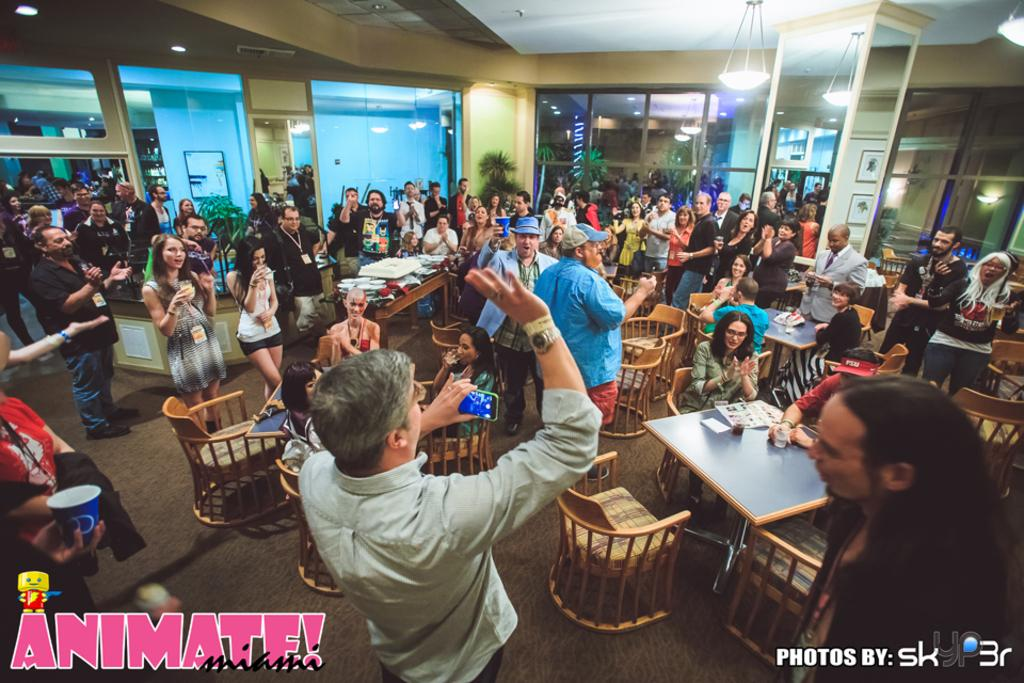What is the man in the image holding? The man is holding a mobile phone. What is the man wearing in the image? The man is wearing a shirt. How many people are in the image? There are other people in the image, in addition to the man. What are some of the people in the image doing? Some people are sitting on chairs, and some people are standing. Where is the light located in the image? The light is on the right side of the image. What type of industry can be seen in the background of the image? There is no industry visible in the image; it primarily features people and a light. Is the man in the image driving a vehicle? No, the man is not driving a vehicle; he is holding a mobile phone. 